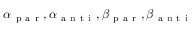<formula> <loc_0><loc_0><loc_500><loc_500>\alpha _ { p a r } , \alpha _ { a n t i } , \beta _ { p a r } , \beta _ { a n t i }</formula> 